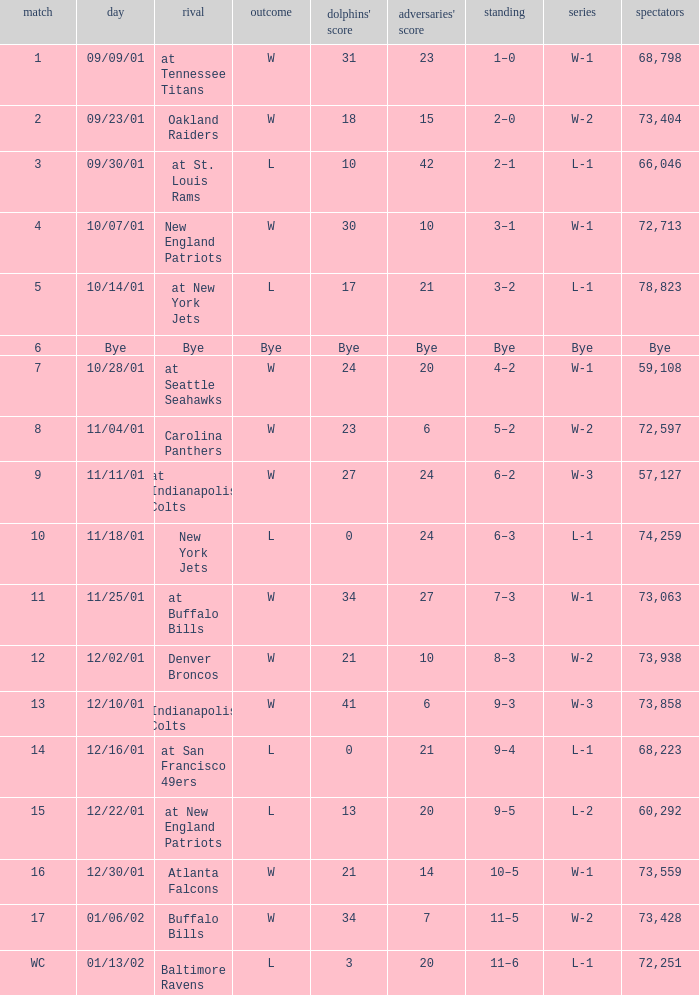What was the attendance of the Oakland Raiders game? 73404.0. Parse the full table. {'header': ['match', 'day', 'rival', 'outcome', "dolphins' score", "adversaries' score", 'standing', 'series', 'spectators'], 'rows': [['1', '09/09/01', 'at Tennessee Titans', 'W', '31', '23', '1–0', 'W-1', '68,798'], ['2', '09/23/01', 'Oakland Raiders', 'W', '18', '15', '2–0', 'W-2', '73,404'], ['3', '09/30/01', 'at St. Louis Rams', 'L', '10', '42', '2–1', 'L-1', '66,046'], ['4', '10/07/01', 'New England Patriots', 'W', '30', '10', '3–1', 'W-1', '72,713'], ['5', '10/14/01', 'at New York Jets', 'L', '17', '21', '3–2', 'L-1', '78,823'], ['6', 'Bye', 'Bye', 'Bye', 'Bye', 'Bye', 'Bye', 'Bye', 'Bye'], ['7', '10/28/01', 'at Seattle Seahawks', 'W', '24', '20', '4–2', 'W-1', '59,108'], ['8', '11/04/01', 'Carolina Panthers', 'W', '23', '6', '5–2', 'W-2', '72,597'], ['9', '11/11/01', 'at Indianapolis Colts', 'W', '27', '24', '6–2', 'W-3', '57,127'], ['10', '11/18/01', 'New York Jets', 'L', '0', '24', '6–3', 'L-1', '74,259'], ['11', '11/25/01', 'at Buffalo Bills', 'W', '34', '27', '7–3', 'W-1', '73,063'], ['12', '12/02/01', 'Denver Broncos', 'W', '21', '10', '8–3', 'W-2', '73,938'], ['13', '12/10/01', 'Indianapolis Colts', 'W', '41', '6', '9–3', 'W-3', '73,858'], ['14', '12/16/01', 'at San Francisco 49ers', 'L', '0', '21', '9–4', 'L-1', '68,223'], ['15', '12/22/01', 'at New England Patriots', 'L', '13', '20', '9–5', 'L-2', '60,292'], ['16', '12/30/01', 'Atlanta Falcons', 'W', '21', '14', '10–5', 'W-1', '73,559'], ['17', '01/06/02', 'Buffalo Bills', 'W', '34', '7', '11–5', 'W-2', '73,428'], ['WC', '01/13/02', 'Baltimore Ravens', 'L', '3', '20', '11–6', 'L-1', '72,251']]} 